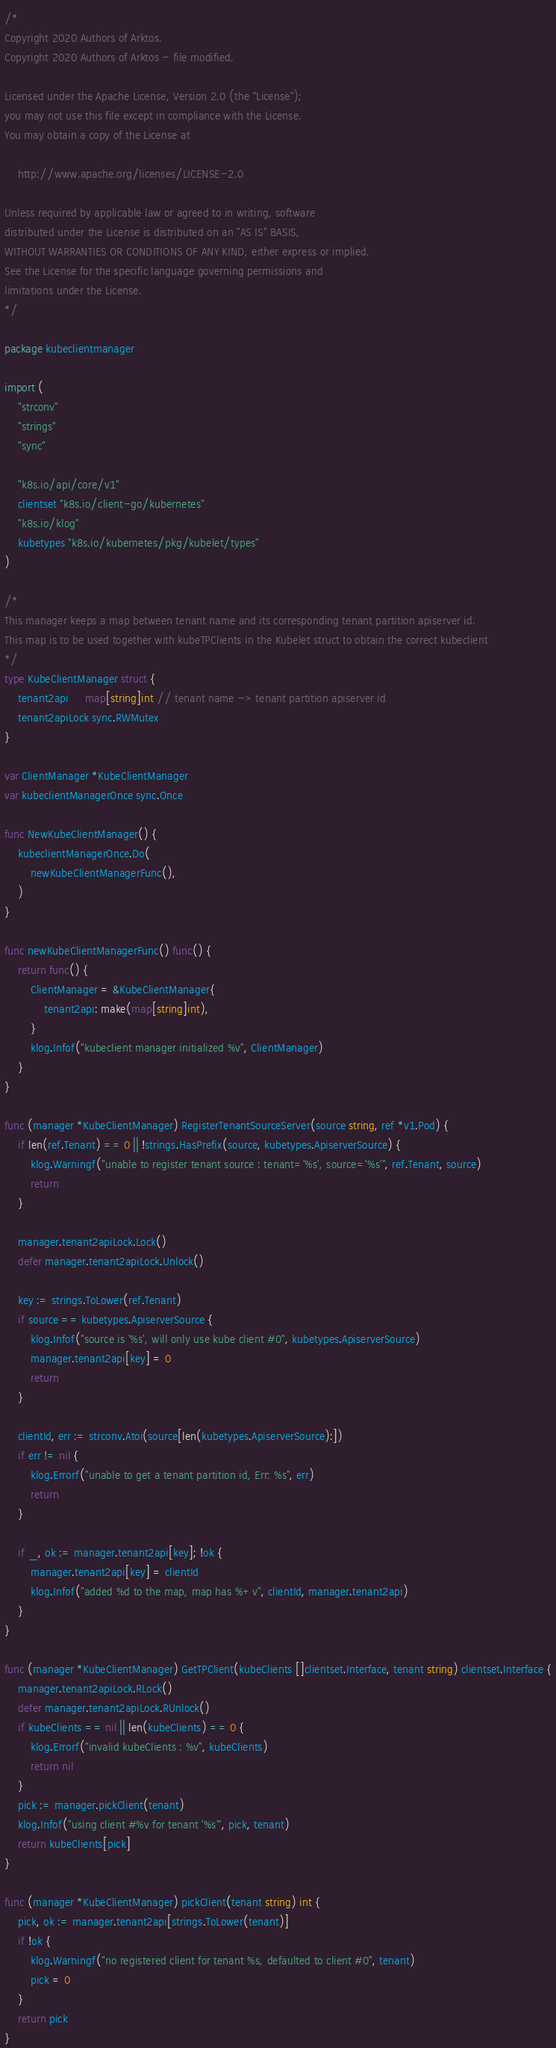Convert code to text. <code><loc_0><loc_0><loc_500><loc_500><_Go_>/*
Copyright 2020 Authors of Arktos.
Copyright 2020 Authors of Arktos - file modified.

Licensed under the Apache License, Version 2.0 (the "License");
you may not use this file except in compliance with the License.
You may obtain a copy of the License at

    http://www.apache.org/licenses/LICENSE-2.0

Unless required by applicable law or agreed to in writing, software
distributed under the License is distributed on an "AS IS" BASIS,
WITHOUT WARRANTIES OR CONDITIONS OF ANY KIND, either express or implied.
See the License for the specific language governing permissions and
limitations under the License.
*/

package kubeclientmanager

import (
	"strconv"
	"strings"
	"sync"

	"k8s.io/api/core/v1"
	clientset "k8s.io/client-go/kubernetes"
	"k8s.io/klog"
	kubetypes "k8s.io/kubernetes/pkg/kubelet/types"
)

/*
This manager keeps a map between tenant name and its corresponding tenant partition apiserver id.
This map is to be used together with kubeTPClients in the Kubelet struct to obtain the correct kubeclient
*/
type KubeClientManager struct {
	tenant2api     map[string]int // tenant name -> tenant partition apiserver id
	tenant2apiLock sync.RWMutex
}

var ClientManager *KubeClientManager
var kubeclientManagerOnce sync.Once

func NewKubeClientManager() {
	kubeclientManagerOnce.Do(
		newKubeClientManagerFunc(),
	)
}

func newKubeClientManagerFunc() func() {
	return func() {
		ClientManager = &KubeClientManager{
			tenant2api: make(map[string]int),
		}
		klog.Infof("kubeclient manager initialized %v", ClientManager)
	}
}

func (manager *KubeClientManager) RegisterTenantSourceServer(source string, ref *v1.Pod) {
	if len(ref.Tenant) == 0 || !strings.HasPrefix(source, kubetypes.ApiserverSource) {
		klog.Warningf("unable to register tenant source : tenant='%s', source='%s'", ref.Tenant, source)
		return
	}

	manager.tenant2apiLock.Lock()
	defer manager.tenant2apiLock.Unlock()

	key := strings.ToLower(ref.Tenant)
	if source == kubetypes.ApiserverSource {
		klog.Infof("source is '%s', will only use kube client #0", kubetypes.ApiserverSource)
		manager.tenant2api[key] = 0
		return
	}

	clientId, err := strconv.Atoi(source[len(kubetypes.ApiserverSource):])
	if err != nil {
		klog.Errorf("unable to get a tenant partition id, Err: %s", err)
		return
	}

	if _, ok := manager.tenant2api[key]; !ok {
		manager.tenant2api[key] = clientId
		klog.Infof("added %d to the map, map has %+v", clientId, manager.tenant2api)
	}
}

func (manager *KubeClientManager) GetTPClient(kubeClients []clientset.Interface, tenant string) clientset.Interface {
	manager.tenant2apiLock.RLock()
	defer manager.tenant2apiLock.RUnlock()
	if kubeClients == nil || len(kubeClients) == 0 {
		klog.Errorf("invalid kubeClients : %v", kubeClients)
		return nil
	}
	pick := manager.pickClient(tenant)
	klog.Infof("using client #%v for tenant '%s'", pick, tenant)
	return kubeClients[pick]
}

func (manager *KubeClientManager) pickClient(tenant string) int {
	pick, ok := manager.tenant2api[strings.ToLower(tenant)]
	if !ok {
		klog.Warningf("no registered client for tenant %s, defaulted to client #0", tenant)
		pick = 0
	}
	return pick
}
</code> 